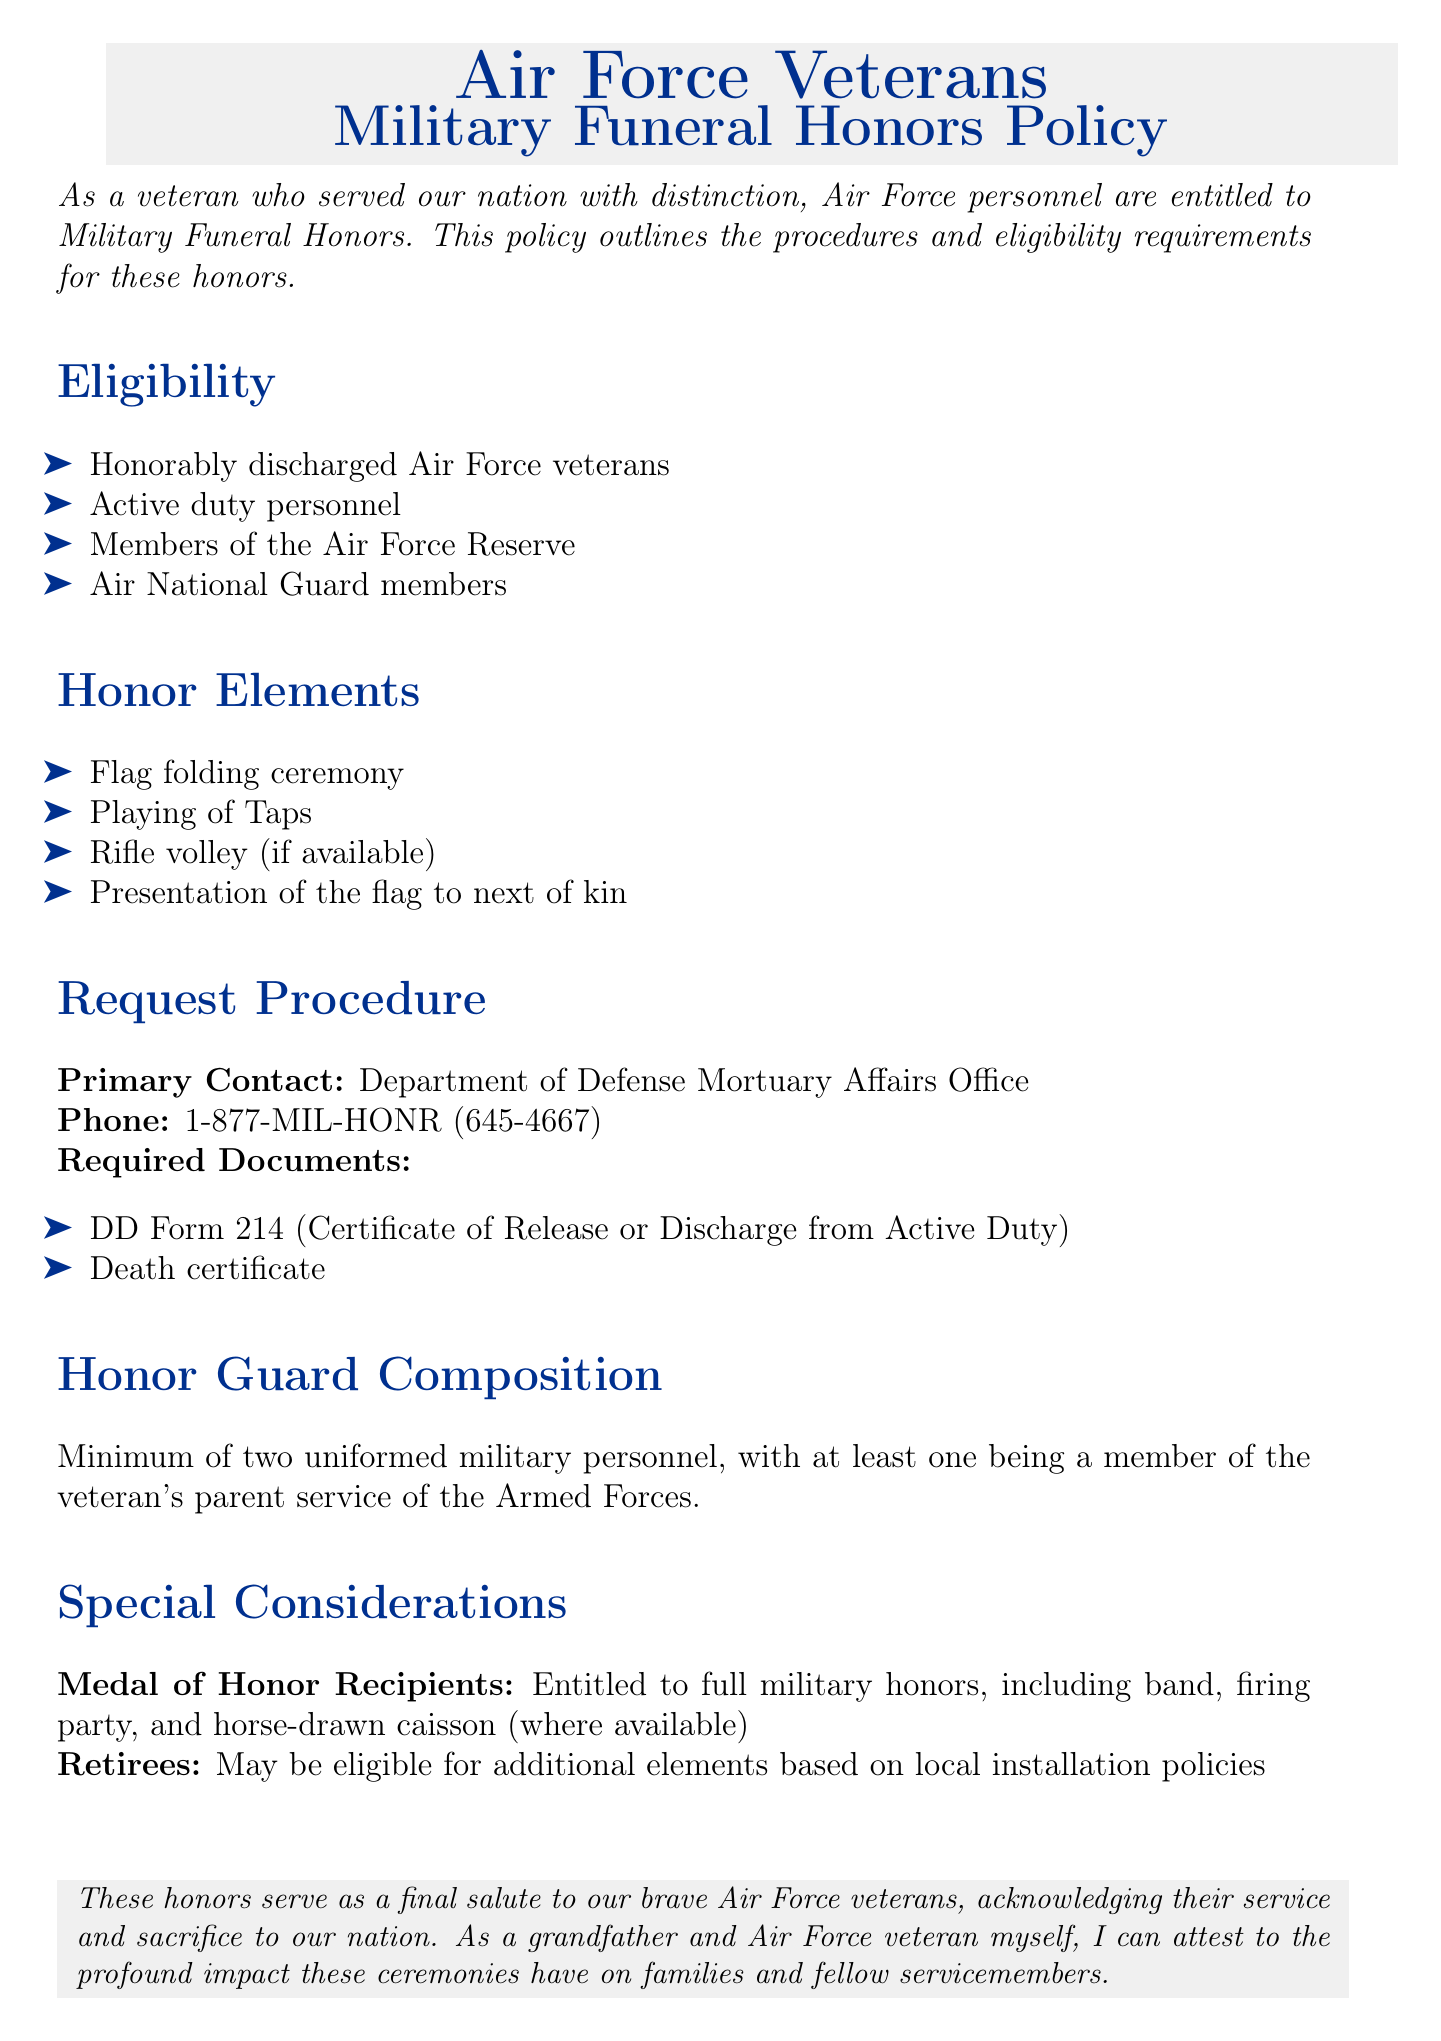What is the primary contact office for funeral honors? The document states that the primary contact for funeral honors is the Department of Defense Mortuary Affairs Office.
Answer: Department of Defense Mortuary Affairs Office How many eligible groups are listed? The eligibility section mentions four specific groups: honorably discharged veterans, active duty personnel, Reserve members, and National Guard members.
Answer: Four What is the phone number for the Mortuary Affairs Office? The document provides the phone number as 1-877-MIL-HONR (645-4667).
Answer: 1-877-MIL-HONR What documents are required for the request procedure? The document lists two required documents: DD Form 214 and a death certificate.
Answer: DD Form 214, death certificate What type of ceremony is mentioned for Medal of Honor recipients? The document indicates that Medal of Honor recipients are entitled to full military honors, which includes a specific type of ceremony.
Answer: Full military honors How many uniformed personnel are required for the Honor Guard? The document specifies that a minimum of two uniformed personnel is required for the Honor Guard.
Answer: Two What element is included in the honor elements? The document lists several elements, including the playing of Taps.
Answer: Playing of Taps Do retirees get additional honors? The document mentions that retirees may be eligible for additional elements based on local installation policies.
Answer: Yes What color is used for section titles? The document uses a specific shade identified as airforceblue for section titles.
Answer: Airforceblue 